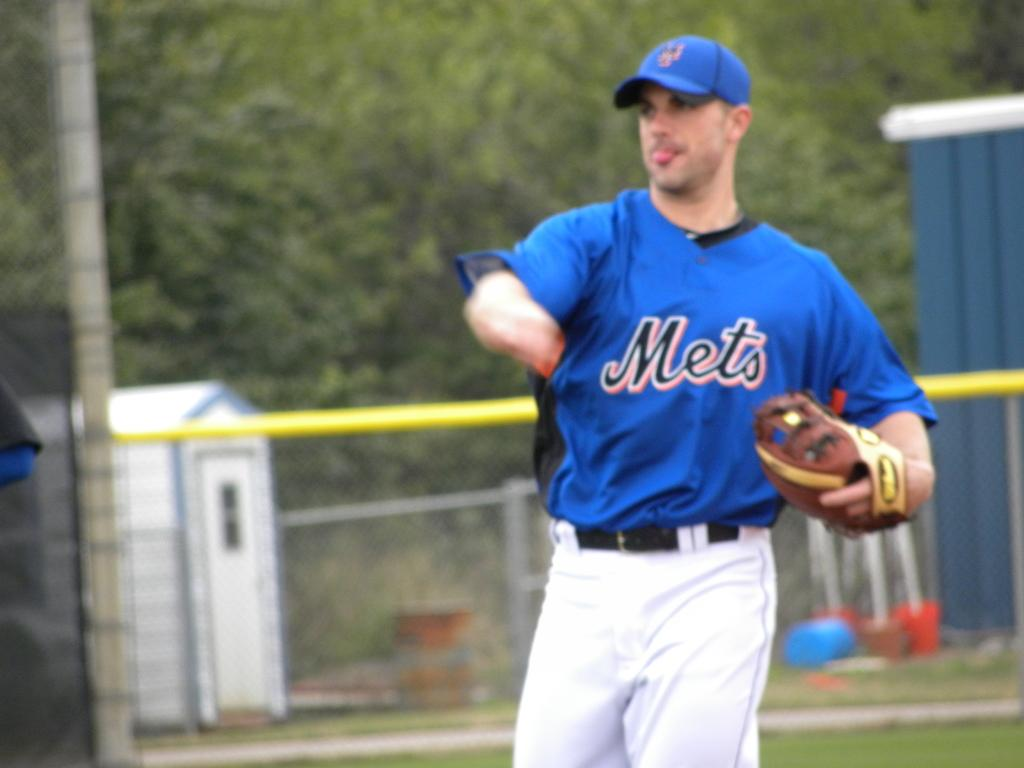<image>
Give a short and clear explanation of the subsequent image. Mets is the team name on this player's baseball jersey. 